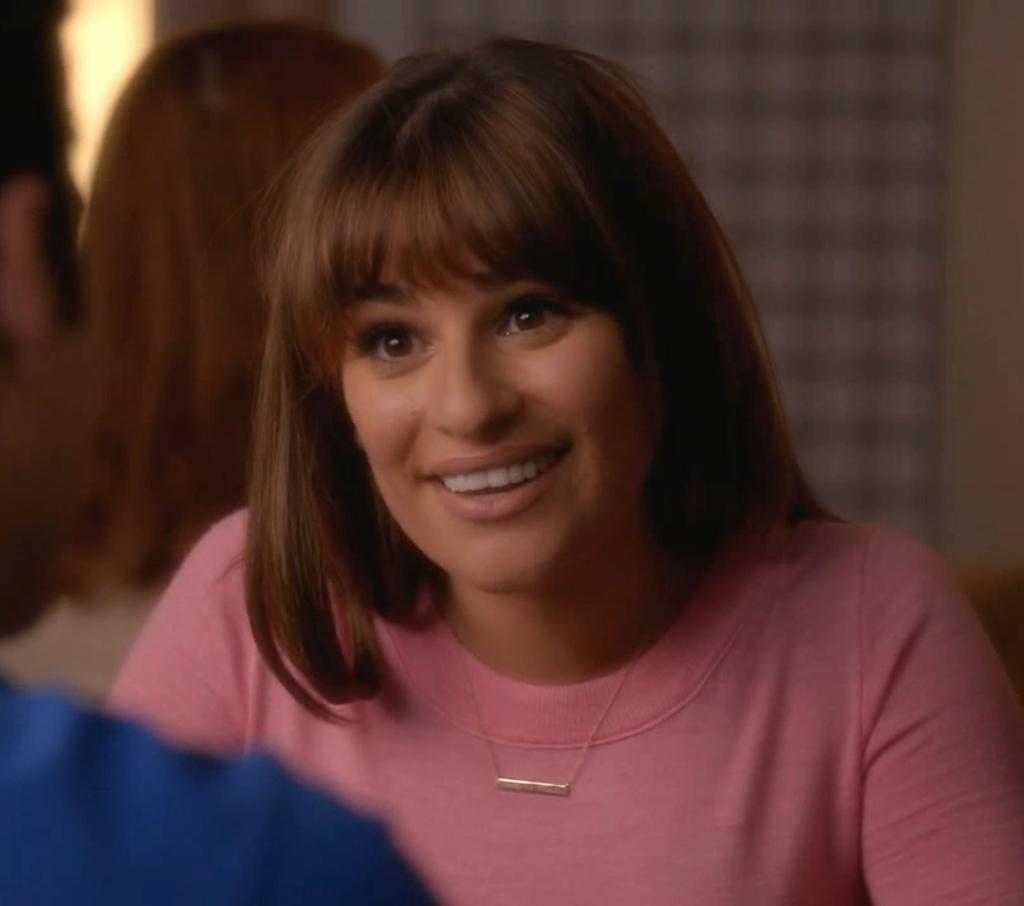How would you summarize this image in a sentence or two? Background portion of the picture is blurred. In this picture we can see a woman and she is smiling. On the left side of the picture we can see the partial part of a man. 